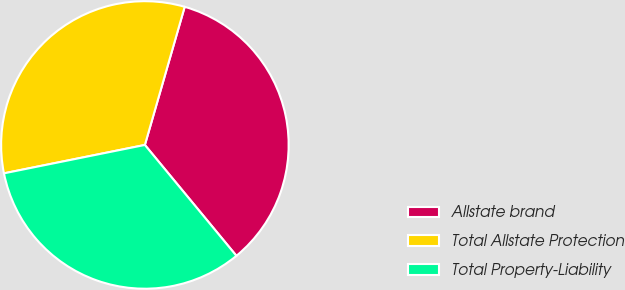<chart> <loc_0><loc_0><loc_500><loc_500><pie_chart><fcel>Allstate brand<fcel>Total Allstate Protection<fcel>Total Property-Liability<nl><fcel>34.55%<fcel>32.63%<fcel>32.82%<nl></chart> 